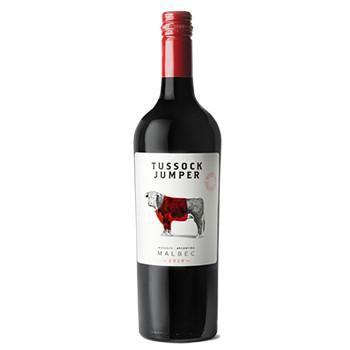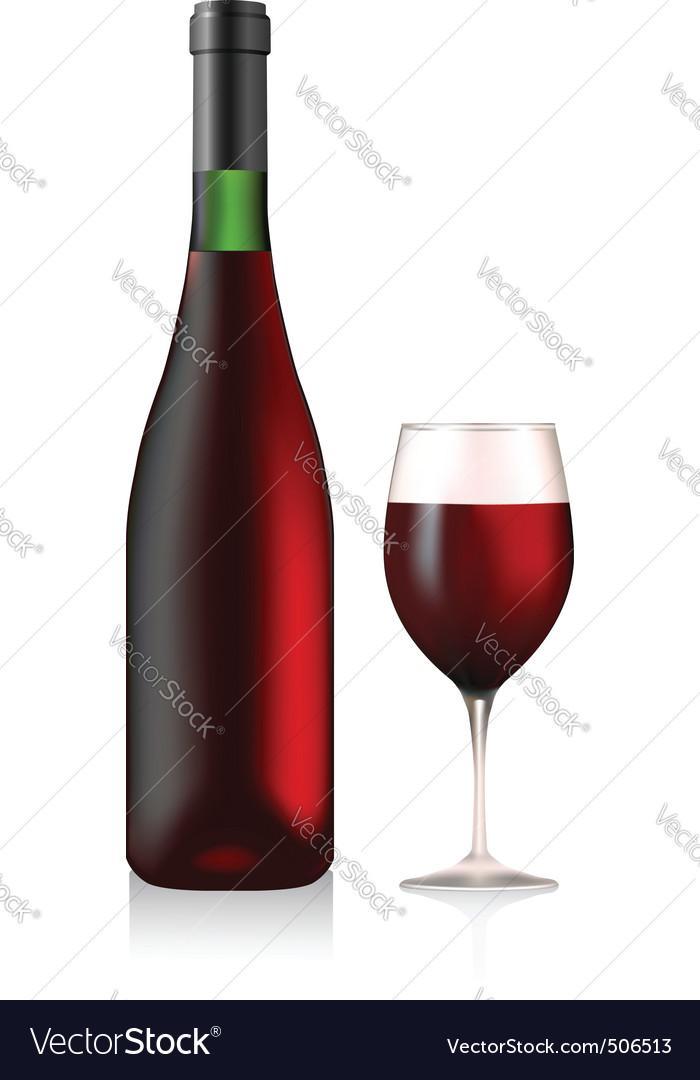The first image is the image on the left, the second image is the image on the right. Evaluate the accuracy of this statement regarding the images: "A large variety of wines is paired with a single bottle with colored top.". Is it true? Answer yes or no. No. 